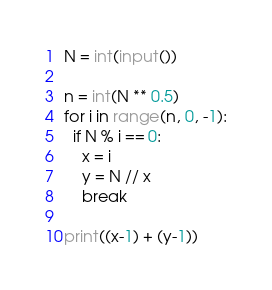<code> <loc_0><loc_0><loc_500><loc_500><_Python_>N = int(input())

n = int(N ** 0.5)
for i in range(n, 0, -1):
  if N % i == 0:
    x = i
    y = N // x
    break

print((x-1) + (y-1))</code> 